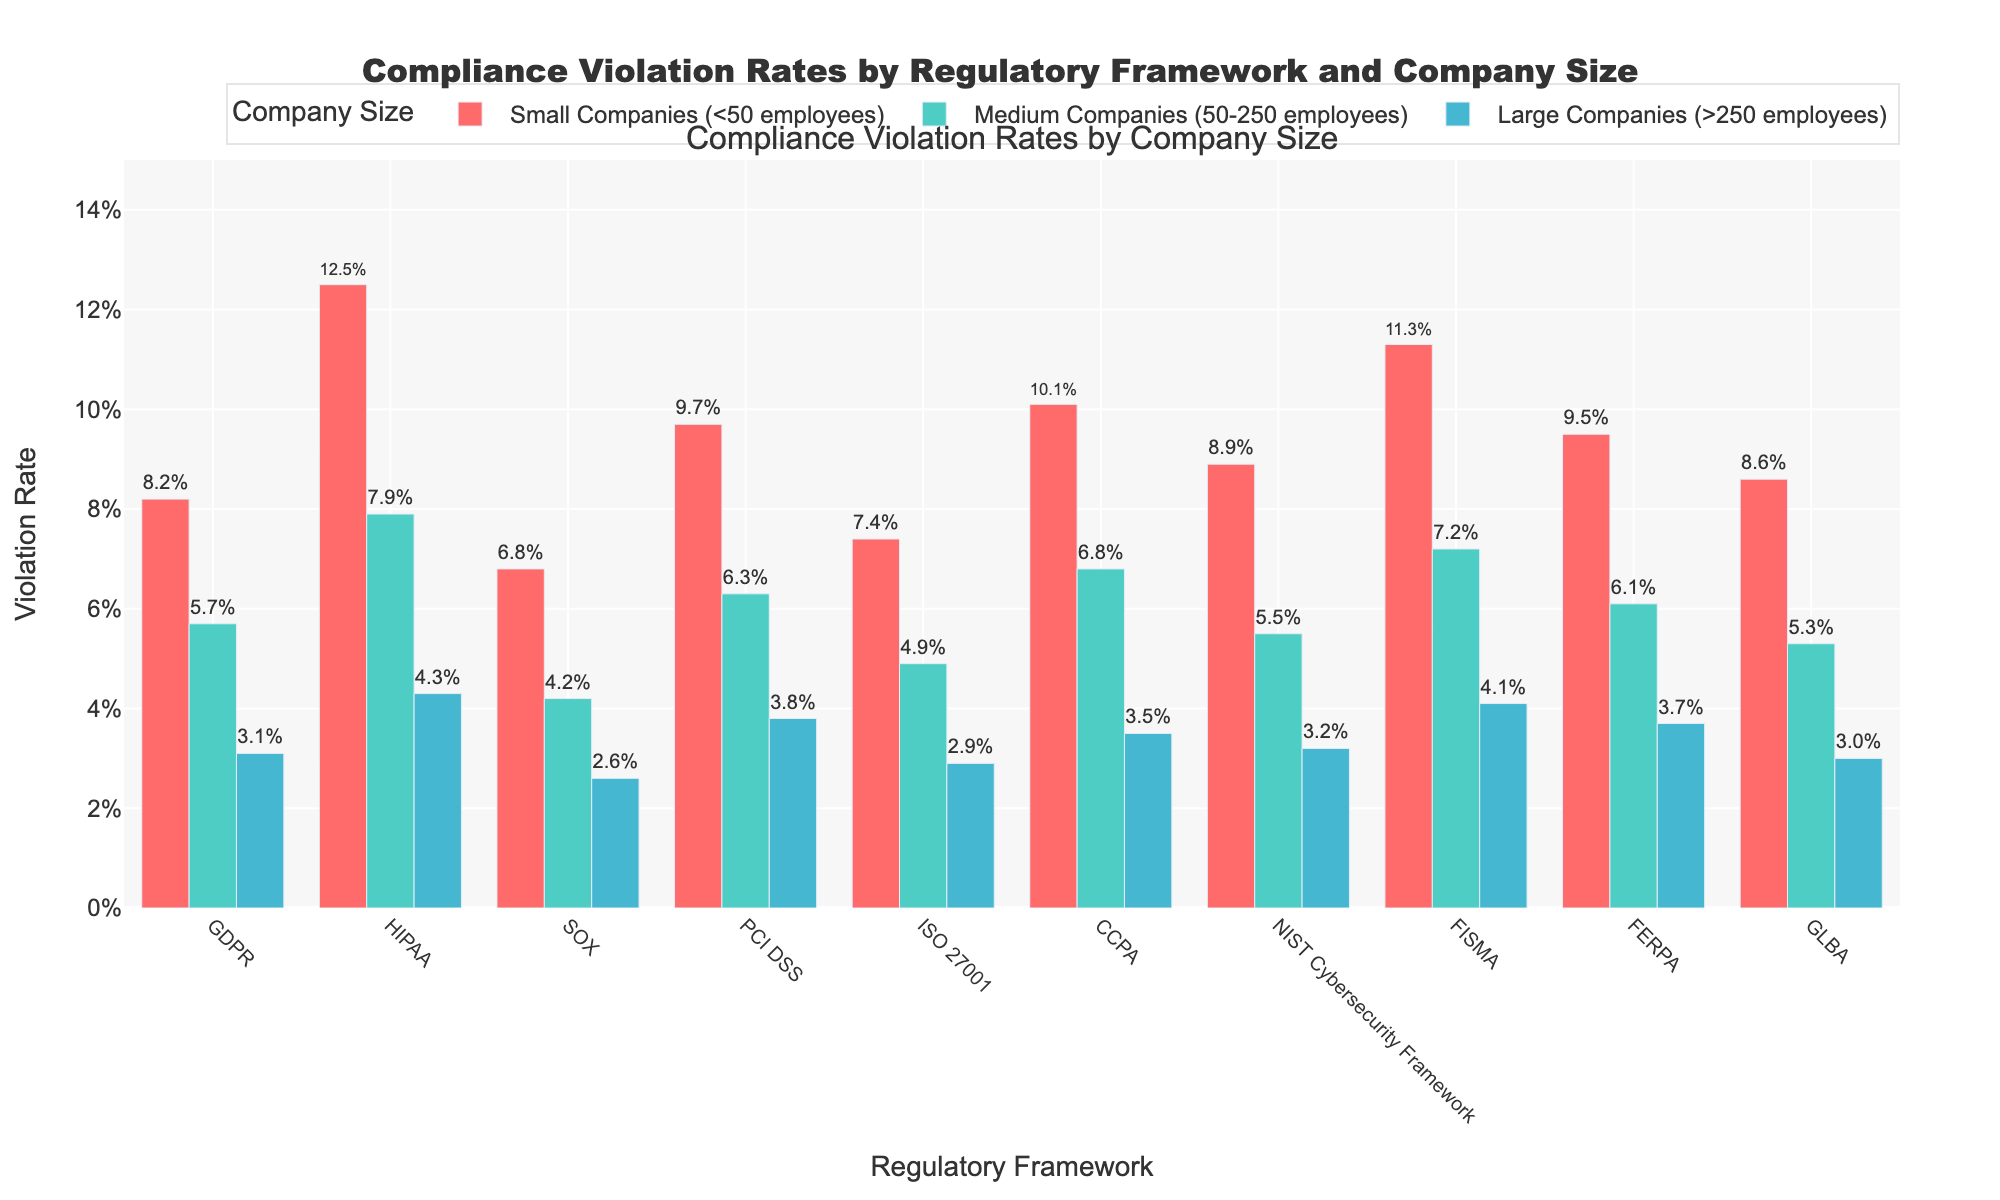Which regulatory framework has the highest compliance violation rate for small companies? The height of the bars for small companies indicates that HIPAA has the highest compliance violation rate among small companies.
Answer: HIPAA For large companies, which regulatory framework has the lowest compliance violation rate? The bar for SOX in large companies is the shortest among all the regulatory frameworks.
Answer: SOX What is the difference in compliance violation rates between small and medium companies for PCI DSS? The compliance violation rate for small companies in PCI DSS is 9.7%, and for medium companies, it is 6.3%. The difference is 9.7% - 6.3%.
Answer: 3.4% What is the average compliance violation rate for GDPR across all company sizes? The compliance violation rates for GDPR are 8.2% for small companies, 5.7% for medium companies, and 3.1% for large companies. The average is (8.2% + 5.7% + 3.1%) / 3.
Answer: 5.7% Which company size shows the least variation in compliance violation rates across all regulatory frameworks? By observing the similarity in the bar heights, large companies have the most consistent (least varying) violation rates compared to small and medium companies.
Answer: Large Companies How many regulatory frameworks have higher compliance violation rates for small companies compared to large companies? Each small company bar is taller than the corresponding large company bar. Counting them, there are 10 regulatory frameworks in total.
Answer: 10 Which regulatory frameworks have a compliance violation rate of more than 10% for small companies? The bars for small companies in HIPAA (12.5%), CCPA (10.1%), and FISMA (11.3%) exceed the 10% mark.
Answer: HIPAA, CCPA, FISMA Is the compliance violation rate for FERPA higher for medium companies or large companies? The bar for FERPA in medium companies (6.1%) is higher than in large companies (3.7%).
Answer: Medium Companies What percentage reduction in compliance violation rate is seen in GDPR when comparing small companies to large companies? The compliance violation rate for GDPR is 8.2% for small companies and 3.1% for large companies. The reduction is (8.2% - 3.1%) / 8.2%.
Answer: 62.2% Out of the three company sizes, which one generally has the lowest compliance violation rates across the presented regulatory frameworks? By visually comparing the heights of the bars, large companies generally have the lowest compliance violation rates.
Answer: Large Companies 